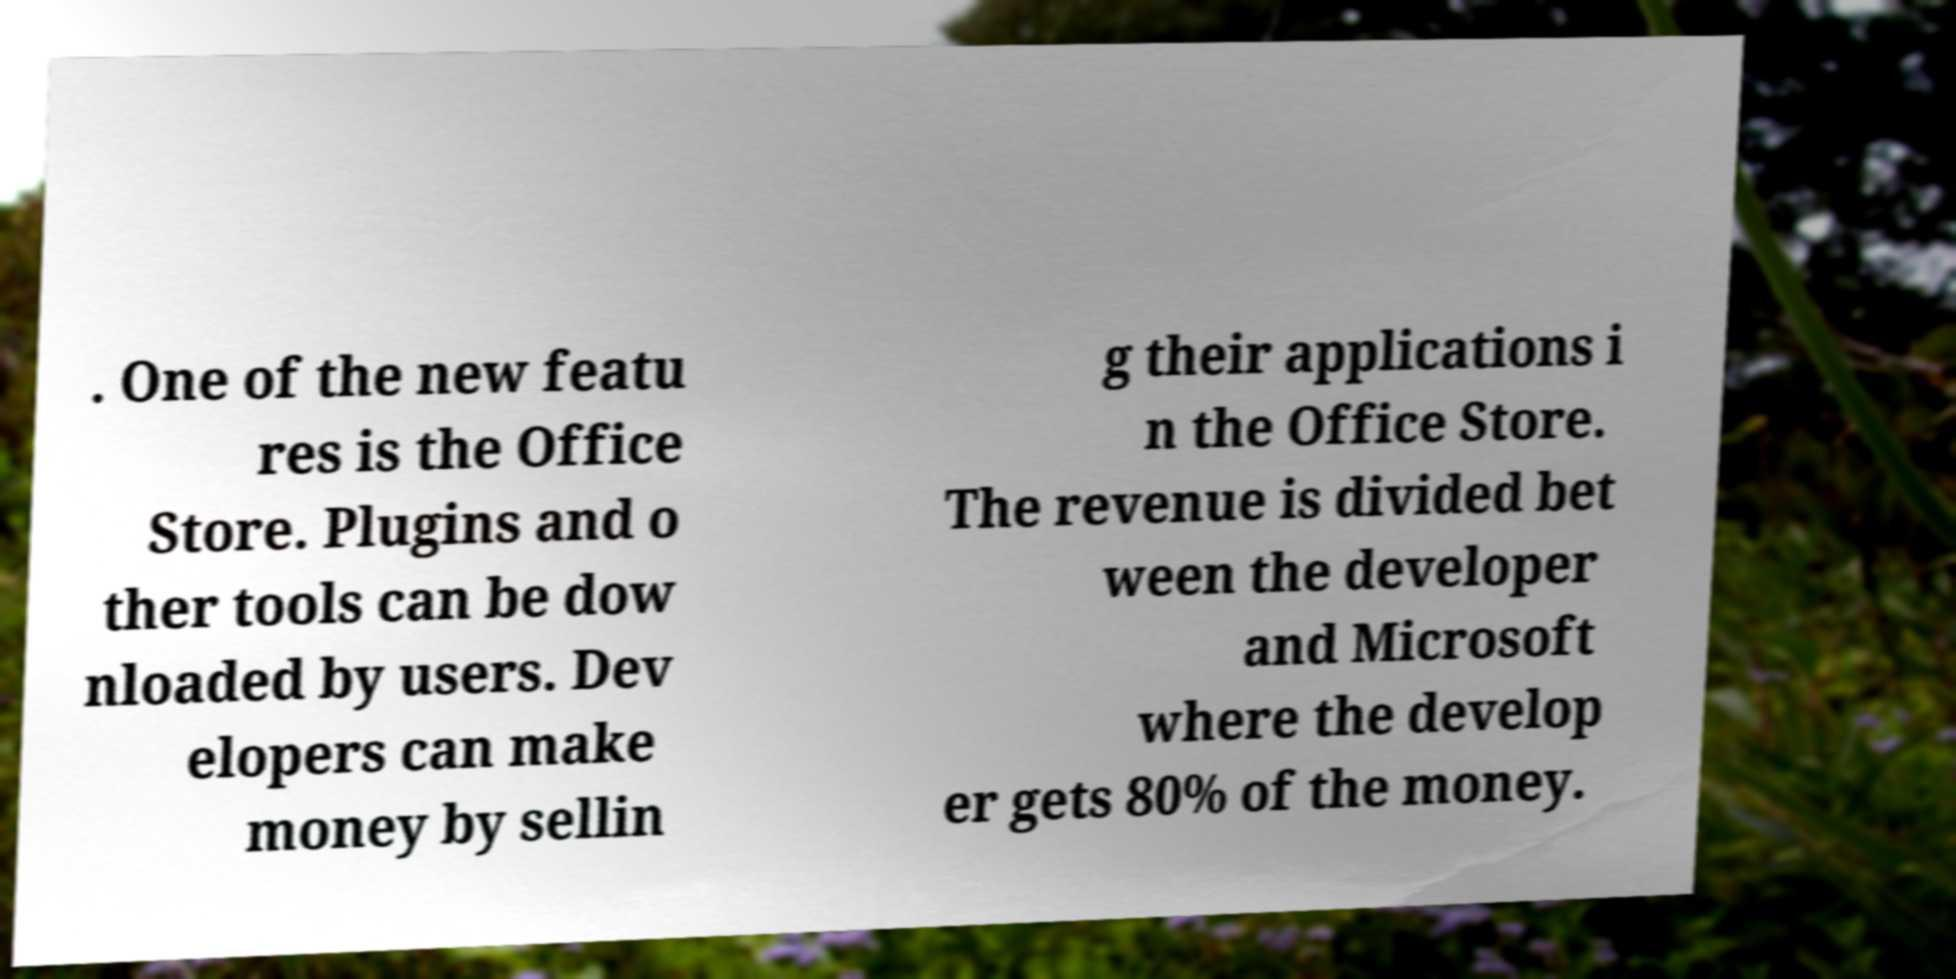I need the written content from this picture converted into text. Can you do that? . One of the new featu res is the Office Store. Plugins and o ther tools can be dow nloaded by users. Dev elopers can make money by sellin g their applications i n the Office Store. The revenue is divided bet ween the developer and Microsoft where the develop er gets 80% of the money. 